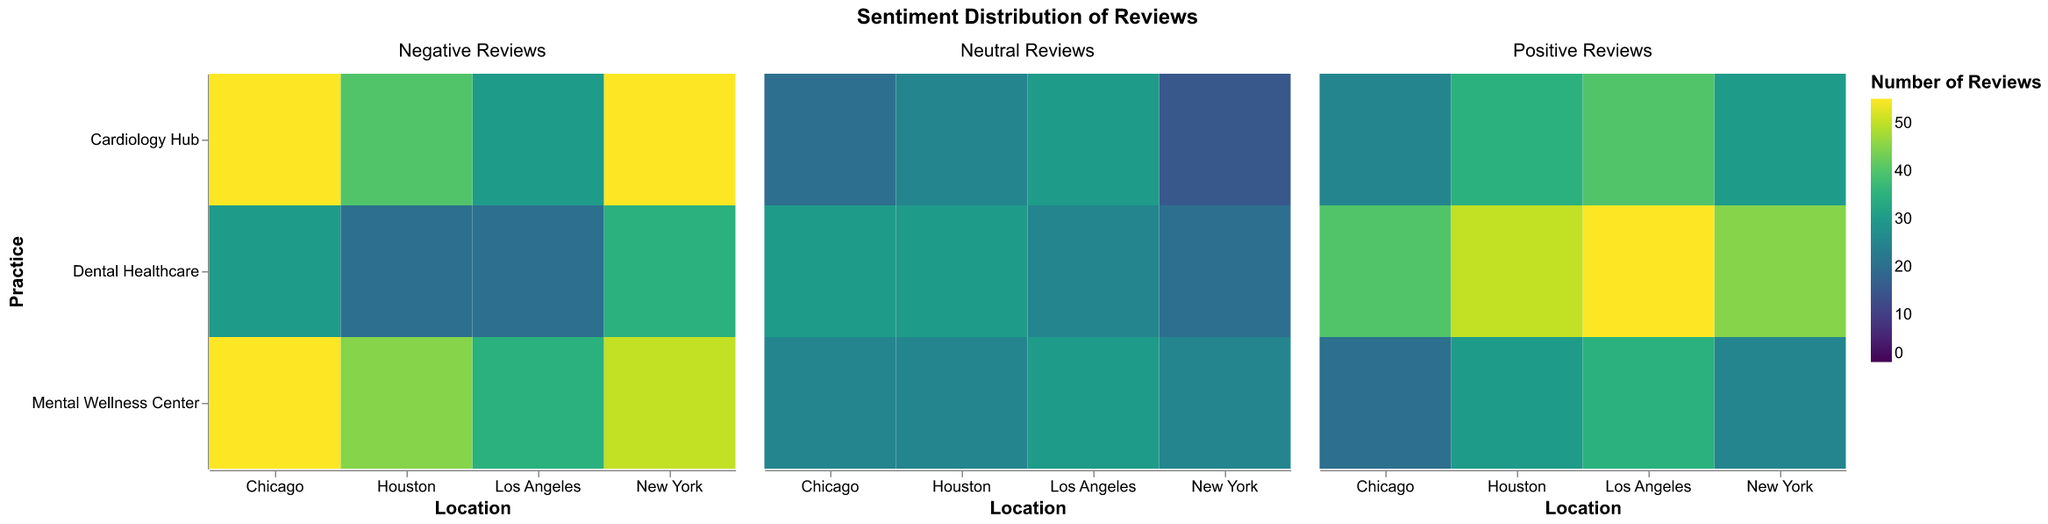What is the total number of positive reviews for 'Dental Healthcare' across all locations? We need to sum the number of positive reviews for 'Dental Healthcare' in each location: New York (45), Los Angeles (55), Chicago (40), and Houston (50). Total = 45 + 55 + 40 + 50 = 190
Answer: 190 Which location has the highest number of negative reviews for 'Cardiology Hub' practice? We compare the number of negative reviews for 'Cardiology Hub' across New York (55), Los Angeles (30), Chicago (55), and Houston (40). Both New York and Chicago have the highest number with 55 negative reviews.
Answer: New York and Chicago What is the average number of neutral reviews for 'Mental Wellness Center' across all locations? We sum the neutral reviews for 'Mental Wellness Center' in each location and then divide by the number of locations. New York (25), Los Angeles (30), Chicago (25), and Houston (25). Average = (25 + 30 + 25 + 25) / 4 = 26.25
Answer: 26.25 Which practice has the lowest number of positive reviews in Chicago? We compare the positive reviews for each practice in Chicago: Cardiology Hub (25), Dental Healthcare (40), and Mental Wellness Center (20). 'Mental Wellness Center' has the lowest number with 20 positive reviews.
Answer: Mental Wellness Center How do the negative reviews for 'Dental Healthcare' practice in Los Angeles compare to those in Houston? In Los Angeles, 'Dental Healthcare' has 20 negative reviews, while in Houston it has 20 negative reviews as well. Therefore, the number is equal.
Answer: Equal (20 each) What is the combined total of negative reviews for 'Mental Wellness Center' across New York and Houston? We add the negative reviews: New York (50) and Houston (45). Total = 50 + 45 = 95
Answer: 95 Which location has the most balanced number of positive and negative reviews for 'Mental Wellness Center'? We need to compare the discrepancy (absolute difference) between positive and negative reviews for 'Mental Wellness Center' in each location: New York (25-50=25), Los Angeles (35-35=0), Chicago (20-55=35), and Houston (30-45=15). Los Angeles has the smallest difference (0), hence it is the most balanced.
Answer: Los Angeles What's the ratio of positive to negative reviews for 'Cardiology Hub' in Los Angeles? The number of positive reviews for 'Cardiology Hub' in Los Angeles is 40, and the number of negative reviews is 30. Ratio = 40/30 ≈ 1.33
Answer: 1.33 Which practice in New York has the highest total number of reviews? To find the total number of reviews for each practice in New York, we sum the respective positive, neutral, and negative reviews: 
- Cardiology Hub: 30 + 15 + 55 = 100
- Dental Healthcare: 45 + 20 + 35 = 100
- Mental Wellness Center: 25 + 25 + 50 = 100
All three practices have an equal total number of reviews at 100.
Answer: All practices (100 each) What is the difference in the number of negative reviews between 'Cardiology Hub' in New York and 'Mental Wellness Center' in Chicago? 'Cardiology Hub' in New York has 55 negative reviews, and 'Mental Wellness Center' in Chicago has 55 negative reviews. The difference is 55 - 55 = 0.
Answer: 0 